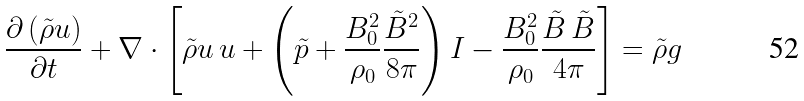Convert formula to latex. <formula><loc_0><loc_0><loc_500><loc_500>\frac { \partial \left ( \tilde { \rho } { u } \right ) } { \partial t } + \nabla \cdot \left [ \tilde { \rho } { u \, u } + \left ( \tilde { p } + \frac { B _ { 0 } ^ { 2 } } { \rho _ { 0 } } \frac { \tilde { B } ^ { 2 } } { 8 \pi } \right ) I - \frac { B _ { 0 } ^ { 2 } } { \rho _ { 0 } } \frac { \tilde { B } \, \tilde { B } } { 4 \pi } \right ] = \tilde { \rho } { g }</formula> 